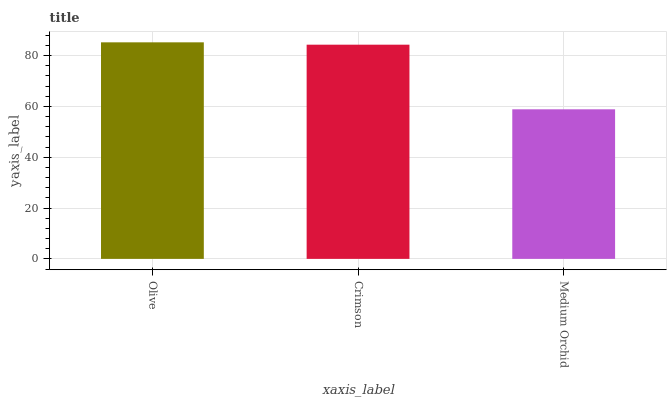Is Medium Orchid the minimum?
Answer yes or no. Yes. Is Olive the maximum?
Answer yes or no. Yes. Is Crimson the minimum?
Answer yes or no. No. Is Crimson the maximum?
Answer yes or no. No. Is Olive greater than Crimson?
Answer yes or no. Yes. Is Crimson less than Olive?
Answer yes or no. Yes. Is Crimson greater than Olive?
Answer yes or no. No. Is Olive less than Crimson?
Answer yes or no. No. Is Crimson the high median?
Answer yes or no. Yes. Is Crimson the low median?
Answer yes or no. Yes. Is Medium Orchid the high median?
Answer yes or no. No. Is Medium Orchid the low median?
Answer yes or no. No. 